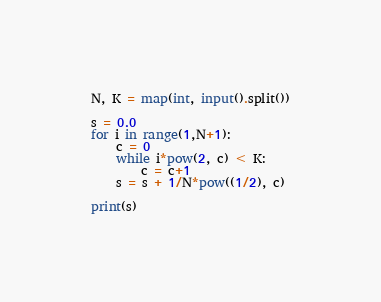<code> <loc_0><loc_0><loc_500><loc_500><_Python_>N, K = map(int, input().split())

s = 0.0
for i in range(1,N+1):
	c = 0
	while i*pow(2, c) < K:
		c = c+1
	s = s + 1/N*pow((1/2), c)
	
print(s)</code> 